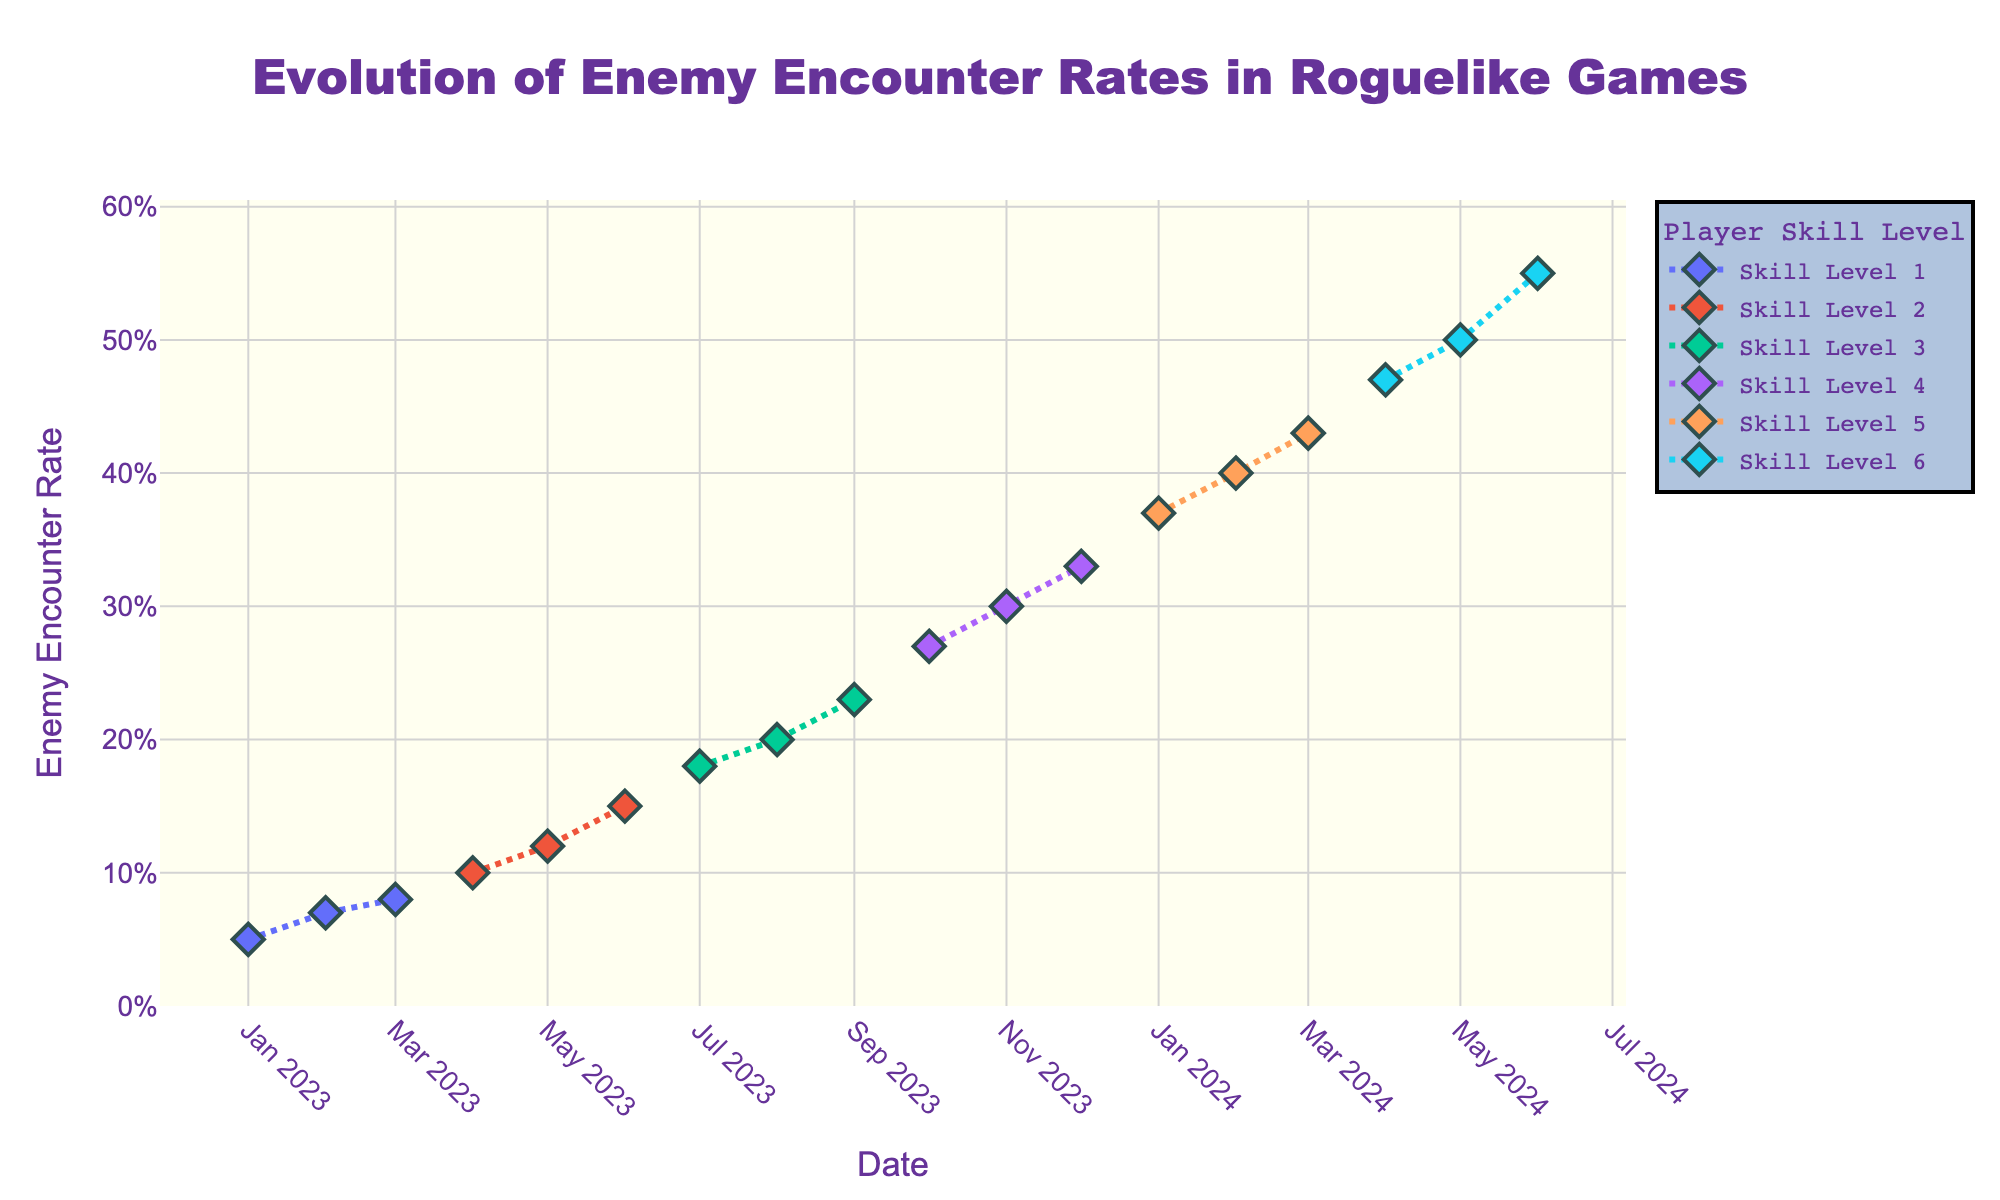What is the time period covered by the figure? The x-axis shows dates ranging from January 2023 to June 2024. By reading the earliest and latest dates on the x-axis, we can determine that the plot covers a period from January 2023 to June 2024.
Answer: January 2023 to June 2024 At which player skill level did the enemy encounter rate first exceed 0.25? By observing the y-axis values and the corresponding player skill levels, the enemy encounter rate first exceeds 0.25 at skill level 4, which is in October 2023.
Answer: Skill level 4 How does the enemy encounter rate change as the player skill level increases from 1 to 6? By noting the y-values for each player skill level, we see that the enemy encounter rate increases as the player skill level increases from 1 to 6, with the rate rising from 0.05 to 0.55.
Answer: Increases What is the general trend of the enemy encounter rate over the time period shown in the plot? Observing the overall progression of the enemy encounter rate across dates, the general trend is an upward movement, indicating that the rate increases over time as player skill levels increase.
Answer: Upward trend Compare the enemy encounter rates for skill levels 3 and 5. Which skill level has the higher encounter rates on average? Averaging the values of enemy encounter rates for skill levels 3 (0.18, 0.20, 0.23) and 5 (0.37, 0.40, 0.43), skill level 5 has higher rates. The averages are calculated as follows: Skill level 3: (0.18 + 0.20 + 0.23) / 3 = 0.203. Skill level 5: (0.37 + 0.40 + 0.43) / 3 = 0.40.
Answer: Skill level 5 What is the enemy encounter rate in June 2024, and how does it compare to the rate in January 2023? The y-value for June 2024 is 0.55, and for January 2023, it is 0.05. Comparing these values, the encounter rate in June 2024 is higher than in January 2023 by 0.50 (0.55 - 0.05).
Answer: 0.55, higher by 0.50 Which month and year did the enemy encounter rate reach 0.12? By locating the y-value of 0.12 on the plot and matching it with the x-axis date, the enemy encounter rate reached 0.12 in May 2023.
Answer: May 2023 What is the percentage increase in the enemy encounter rate from April 2023 to April 2024? The rate in April 2023 is 0.08, and in April 2024 it is 0.47. The percentage increase is calculated as ((0.47 - 0.08) / 0.08) * 100% = 487.5%.
Answer: 487.5% How many skill levels are shown in the figure? By observing the different lines and their labels on the legend, the figure shows six distinct player skill levels ranging from 1 to 6.
Answer: Six Which player skill level has the steepest increase in enemy encounter rate, and during which period does this occur? By analyzing the slopes of the lines, skill level 6 has the steepest increase, which occurs from April 2024 (0.47) to June 2024 (0.55). The increase is 0.08 over two months.
Answer: Skill level 6, April 2024 to June 2024 